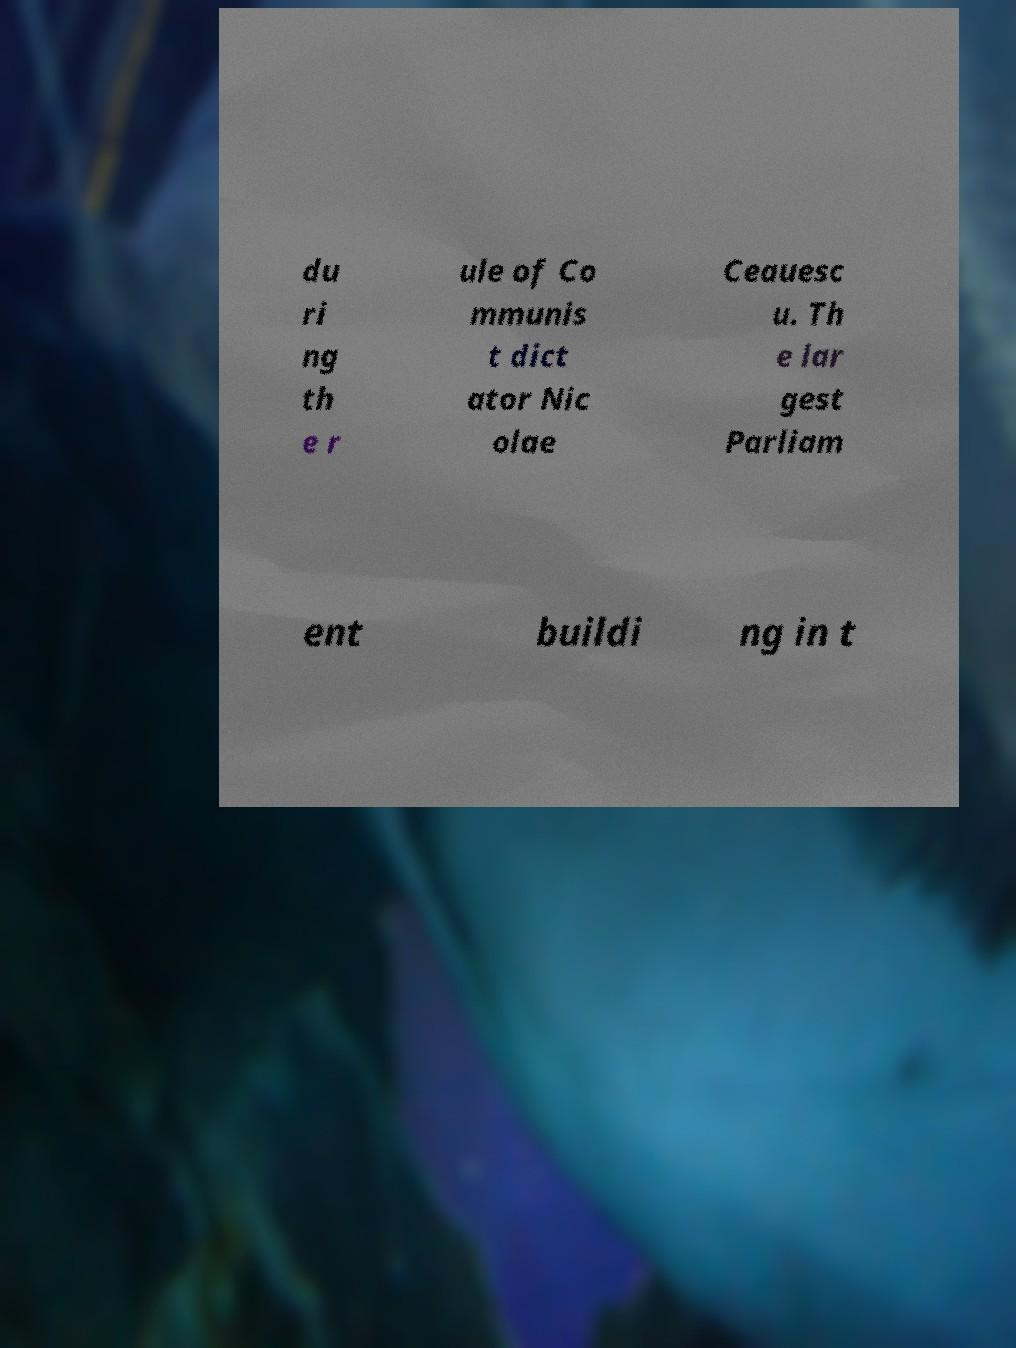Please read and relay the text visible in this image. What does it say? du ri ng th e r ule of Co mmunis t dict ator Nic olae Ceauesc u. Th e lar gest Parliam ent buildi ng in t 